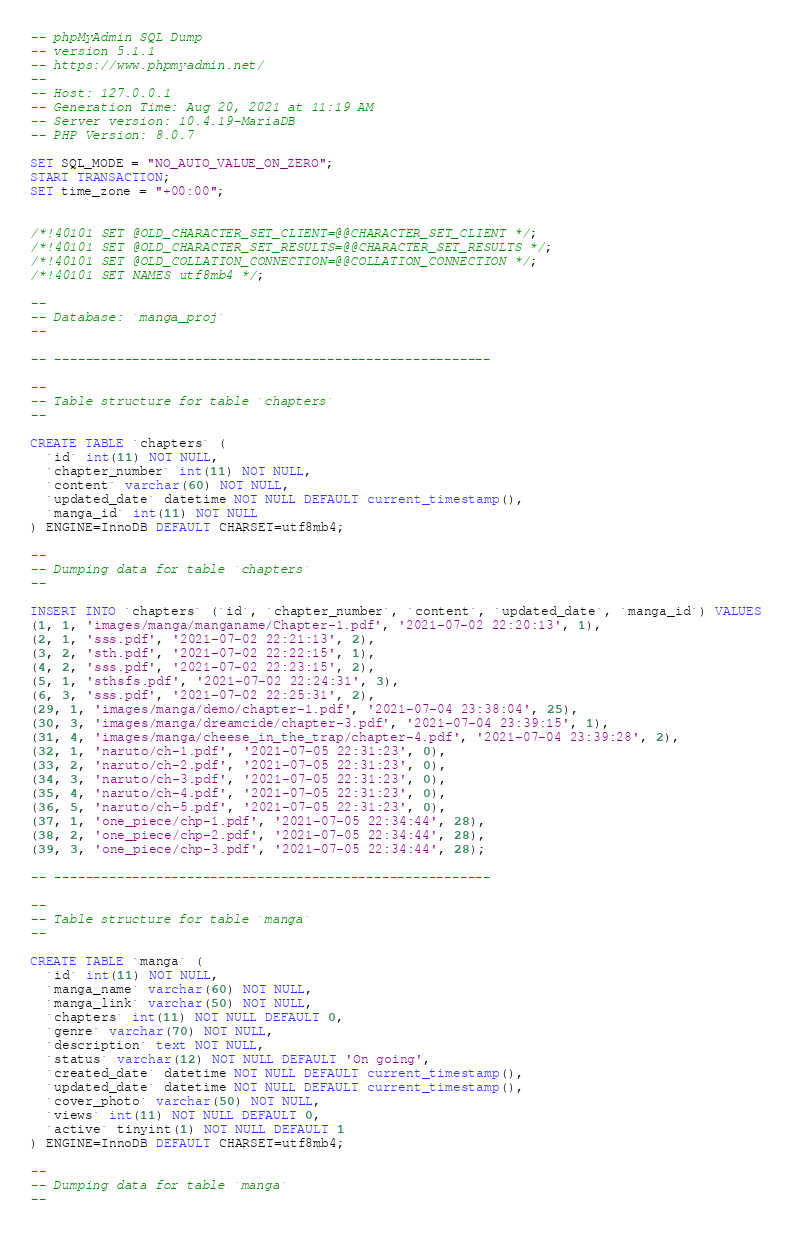Convert code to text. <code><loc_0><loc_0><loc_500><loc_500><_SQL_>-- phpMyAdmin SQL Dump
-- version 5.1.1
-- https://www.phpmyadmin.net/
--
-- Host: 127.0.0.1
-- Generation Time: Aug 20, 2021 at 11:19 AM
-- Server version: 10.4.19-MariaDB
-- PHP Version: 8.0.7

SET SQL_MODE = "NO_AUTO_VALUE_ON_ZERO";
START TRANSACTION;
SET time_zone = "+00:00";


/*!40101 SET @OLD_CHARACTER_SET_CLIENT=@@CHARACTER_SET_CLIENT */;
/*!40101 SET @OLD_CHARACTER_SET_RESULTS=@@CHARACTER_SET_RESULTS */;
/*!40101 SET @OLD_COLLATION_CONNECTION=@@COLLATION_CONNECTION */;
/*!40101 SET NAMES utf8mb4 */;

--
-- Database: `manga_proj`
--

-- --------------------------------------------------------

--
-- Table structure for table `chapters`
--

CREATE TABLE `chapters` (
  `id` int(11) NOT NULL,
  `chapter_number` int(11) NOT NULL,
  `content` varchar(60) NOT NULL,
  `updated_date` datetime NOT NULL DEFAULT current_timestamp(),
  `manga_id` int(11) NOT NULL
) ENGINE=InnoDB DEFAULT CHARSET=utf8mb4;

--
-- Dumping data for table `chapters`
--

INSERT INTO `chapters` (`id`, `chapter_number`, `content`, `updated_date`, `manga_id`) VALUES
(1, 1, 'images/manga/manganame/Chapter-1.pdf', '2021-07-02 22:20:13', 1),
(2, 1, 'sss.pdf', '2021-07-02 22:21:13', 2),
(3, 2, 'sth.pdf', '2021-07-02 22:22:15', 1),
(4, 2, 'sss.pdf', '2021-07-02 22:23:15', 2),
(5, 1, 'sthsfs.pdf', '2021-07-02 22:24:31', 3),
(6, 3, 'sss.pdf', '2021-07-02 22:25:31', 2),
(29, 1, 'images/manga/demo/chapter-1.pdf', '2021-07-04 23:38:04', 25),
(30, 3, 'images/manga/dreamcide/chapter-3.pdf', '2021-07-04 23:39:15', 1),
(31, 4, 'images/manga/cheese_in_the_trap/chapter-4.pdf', '2021-07-04 23:39:28', 2),
(32, 1, 'naruto/ch-1.pdf', '2021-07-05 22:31:23', 0),
(33, 2, 'naruto/ch-2.pdf', '2021-07-05 22:31:23', 0),
(34, 3, 'naruto/ch-3.pdf', '2021-07-05 22:31:23', 0),
(35, 4, 'naruto/ch-4.pdf', '2021-07-05 22:31:23', 0),
(36, 5, 'naruto/ch-5.pdf', '2021-07-05 22:31:23', 0),
(37, 1, 'one_piece/chp-1.pdf', '2021-07-05 22:34:44', 28),
(38, 2, 'one_piece/chp-2.pdf', '2021-07-05 22:34:44', 28),
(39, 3, 'one_piece/chp-3.pdf', '2021-07-05 22:34:44', 28);

-- --------------------------------------------------------

--
-- Table structure for table `manga`
--

CREATE TABLE `manga` (
  `id` int(11) NOT NULL,
  `manga_name` varchar(60) NOT NULL,
  `manga_link` varchar(50) NOT NULL,
  `chapters` int(11) NOT NULL DEFAULT 0,
  `genre` varchar(70) NOT NULL,
  `description` text NOT NULL,
  `status` varchar(12) NOT NULL DEFAULT 'On going',
  `created_date` datetime NOT NULL DEFAULT current_timestamp(),
  `updated_date` datetime NOT NULL DEFAULT current_timestamp(),
  `cover_photo` varchar(50) NOT NULL,
  `views` int(11) NOT NULL DEFAULT 0,
  `active` tinyint(1) NOT NULL DEFAULT 1
) ENGINE=InnoDB DEFAULT CHARSET=utf8mb4;

--
-- Dumping data for table `manga`
--
</code> 